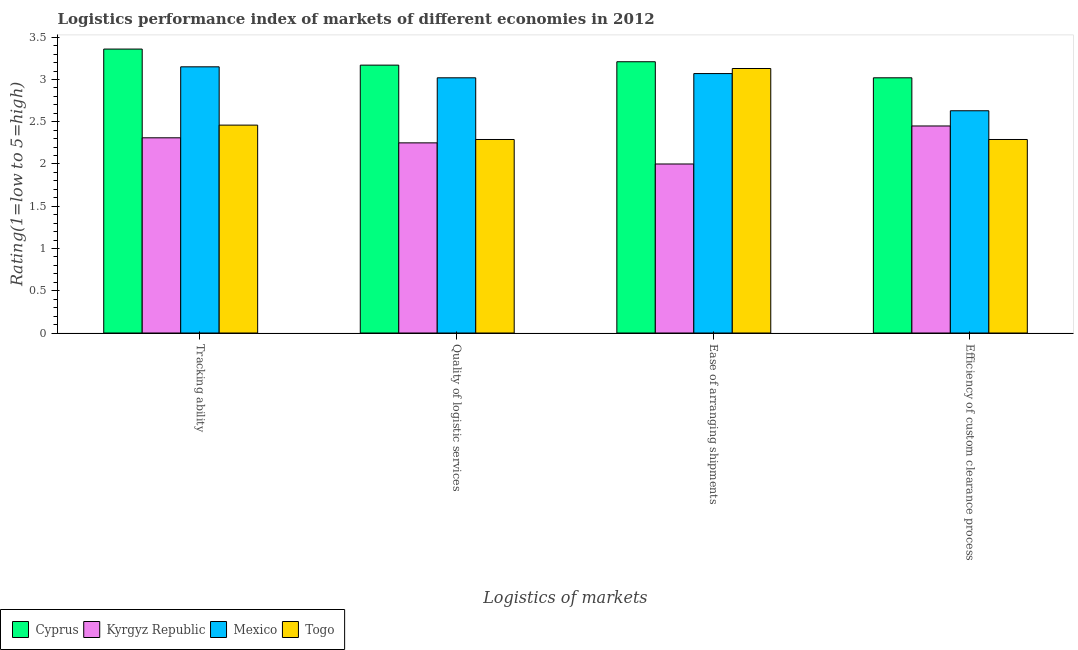How many different coloured bars are there?
Your response must be concise. 4. How many groups of bars are there?
Your answer should be compact. 4. How many bars are there on the 4th tick from the right?
Provide a short and direct response. 4. What is the label of the 1st group of bars from the left?
Make the answer very short. Tracking ability. Across all countries, what is the maximum lpi rating of efficiency of custom clearance process?
Make the answer very short. 3.02. Across all countries, what is the minimum lpi rating of quality of logistic services?
Your answer should be compact. 2.25. In which country was the lpi rating of efficiency of custom clearance process maximum?
Ensure brevity in your answer.  Cyprus. In which country was the lpi rating of quality of logistic services minimum?
Give a very brief answer. Kyrgyz Republic. What is the total lpi rating of ease of arranging shipments in the graph?
Offer a terse response. 11.41. What is the difference between the lpi rating of tracking ability in Kyrgyz Republic and that in Mexico?
Give a very brief answer. -0.84. What is the difference between the lpi rating of efficiency of custom clearance process in Mexico and the lpi rating of tracking ability in Cyprus?
Ensure brevity in your answer.  -0.73. What is the average lpi rating of ease of arranging shipments per country?
Provide a succinct answer. 2.85. What is the difference between the lpi rating of efficiency of custom clearance process and lpi rating of ease of arranging shipments in Cyprus?
Provide a short and direct response. -0.19. In how many countries, is the lpi rating of tracking ability greater than 2.8 ?
Your answer should be very brief. 2. What is the ratio of the lpi rating of ease of arranging shipments in Kyrgyz Republic to that in Cyprus?
Your answer should be compact. 0.62. Is the difference between the lpi rating of quality of logistic services in Kyrgyz Republic and Mexico greater than the difference between the lpi rating of efficiency of custom clearance process in Kyrgyz Republic and Mexico?
Your answer should be very brief. No. What is the difference between the highest and the second highest lpi rating of ease of arranging shipments?
Your answer should be very brief. 0.08. What is the difference between the highest and the lowest lpi rating of quality of logistic services?
Give a very brief answer. 0.92. In how many countries, is the lpi rating of ease of arranging shipments greater than the average lpi rating of ease of arranging shipments taken over all countries?
Provide a succinct answer. 3. What does the 2nd bar from the left in Ease of arranging shipments represents?
Keep it short and to the point. Kyrgyz Republic. What does the 1st bar from the right in Quality of logistic services represents?
Make the answer very short. Togo. Is it the case that in every country, the sum of the lpi rating of tracking ability and lpi rating of quality of logistic services is greater than the lpi rating of ease of arranging shipments?
Keep it short and to the point. Yes. How many bars are there?
Provide a short and direct response. 16. How many countries are there in the graph?
Provide a succinct answer. 4. What is the difference between two consecutive major ticks on the Y-axis?
Give a very brief answer. 0.5. Are the values on the major ticks of Y-axis written in scientific E-notation?
Give a very brief answer. No. Where does the legend appear in the graph?
Your answer should be very brief. Bottom left. How many legend labels are there?
Make the answer very short. 4. What is the title of the graph?
Provide a succinct answer. Logistics performance index of markets of different economies in 2012. What is the label or title of the X-axis?
Your answer should be very brief. Logistics of markets. What is the label or title of the Y-axis?
Offer a terse response. Rating(1=low to 5=high). What is the Rating(1=low to 5=high) of Cyprus in Tracking ability?
Make the answer very short. 3.36. What is the Rating(1=low to 5=high) in Kyrgyz Republic in Tracking ability?
Offer a terse response. 2.31. What is the Rating(1=low to 5=high) in Mexico in Tracking ability?
Ensure brevity in your answer.  3.15. What is the Rating(1=low to 5=high) of Togo in Tracking ability?
Keep it short and to the point. 2.46. What is the Rating(1=low to 5=high) in Cyprus in Quality of logistic services?
Provide a short and direct response. 3.17. What is the Rating(1=low to 5=high) in Kyrgyz Republic in Quality of logistic services?
Provide a short and direct response. 2.25. What is the Rating(1=low to 5=high) in Mexico in Quality of logistic services?
Provide a succinct answer. 3.02. What is the Rating(1=low to 5=high) in Togo in Quality of logistic services?
Your response must be concise. 2.29. What is the Rating(1=low to 5=high) of Cyprus in Ease of arranging shipments?
Ensure brevity in your answer.  3.21. What is the Rating(1=low to 5=high) in Mexico in Ease of arranging shipments?
Your response must be concise. 3.07. What is the Rating(1=low to 5=high) of Togo in Ease of arranging shipments?
Provide a succinct answer. 3.13. What is the Rating(1=low to 5=high) of Cyprus in Efficiency of custom clearance process?
Make the answer very short. 3.02. What is the Rating(1=low to 5=high) of Kyrgyz Republic in Efficiency of custom clearance process?
Offer a terse response. 2.45. What is the Rating(1=low to 5=high) in Mexico in Efficiency of custom clearance process?
Provide a succinct answer. 2.63. What is the Rating(1=low to 5=high) of Togo in Efficiency of custom clearance process?
Provide a short and direct response. 2.29. Across all Logistics of markets, what is the maximum Rating(1=low to 5=high) in Cyprus?
Your response must be concise. 3.36. Across all Logistics of markets, what is the maximum Rating(1=low to 5=high) in Kyrgyz Republic?
Your answer should be compact. 2.45. Across all Logistics of markets, what is the maximum Rating(1=low to 5=high) in Mexico?
Offer a very short reply. 3.15. Across all Logistics of markets, what is the maximum Rating(1=low to 5=high) in Togo?
Provide a succinct answer. 3.13. Across all Logistics of markets, what is the minimum Rating(1=low to 5=high) of Cyprus?
Offer a terse response. 3.02. Across all Logistics of markets, what is the minimum Rating(1=low to 5=high) of Mexico?
Your answer should be compact. 2.63. Across all Logistics of markets, what is the minimum Rating(1=low to 5=high) in Togo?
Make the answer very short. 2.29. What is the total Rating(1=low to 5=high) in Cyprus in the graph?
Your answer should be compact. 12.76. What is the total Rating(1=low to 5=high) of Kyrgyz Republic in the graph?
Your response must be concise. 9.01. What is the total Rating(1=low to 5=high) in Mexico in the graph?
Make the answer very short. 11.87. What is the total Rating(1=low to 5=high) in Togo in the graph?
Your answer should be compact. 10.17. What is the difference between the Rating(1=low to 5=high) of Cyprus in Tracking ability and that in Quality of logistic services?
Your response must be concise. 0.19. What is the difference between the Rating(1=low to 5=high) in Kyrgyz Republic in Tracking ability and that in Quality of logistic services?
Your answer should be compact. 0.06. What is the difference between the Rating(1=low to 5=high) in Mexico in Tracking ability and that in Quality of logistic services?
Ensure brevity in your answer.  0.13. What is the difference between the Rating(1=low to 5=high) of Togo in Tracking ability and that in Quality of logistic services?
Ensure brevity in your answer.  0.17. What is the difference between the Rating(1=low to 5=high) of Kyrgyz Republic in Tracking ability and that in Ease of arranging shipments?
Offer a very short reply. 0.31. What is the difference between the Rating(1=low to 5=high) in Togo in Tracking ability and that in Ease of arranging shipments?
Offer a very short reply. -0.67. What is the difference between the Rating(1=low to 5=high) in Cyprus in Tracking ability and that in Efficiency of custom clearance process?
Keep it short and to the point. 0.34. What is the difference between the Rating(1=low to 5=high) in Kyrgyz Republic in Tracking ability and that in Efficiency of custom clearance process?
Provide a short and direct response. -0.14. What is the difference between the Rating(1=low to 5=high) of Mexico in Tracking ability and that in Efficiency of custom clearance process?
Your answer should be very brief. 0.52. What is the difference between the Rating(1=low to 5=high) in Togo in Tracking ability and that in Efficiency of custom clearance process?
Your answer should be very brief. 0.17. What is the difference between the Rating(1=low to 5=high) of Cyprus in Quality of logistic services and that in Ease of arranging shipments?
Provide a succinct answer. -0.04. What is the difference between the Rating(1=low to 5=high) in Togo in Quality of logistic services and that in Ease of arranging shipments?
Give a very brief answer. -0.84. What is the difference between the Rating(1=low to 5=high) in Cyprus in Quality of logistic services and that in Efficiency of custom clearance process?
Provide a succinct answer. 0.15. What is the difference between the Rating(1=low to 5=high) in Mexico in Quality of logistic services and that in Efficiency of custom clearance process?
Offer a very short reply. 0.39. What is the difference between the Rating(1=low to 5=high) of Togo in Quality of logistic services and that in Efficiency of custom clearance process?
Your answer should be very brief. 0. What is the difference between the Rating(1=low to 5=high) of Cyprus in Ease of arranging shipments and that in Efficiency of custom clearance process?
Ensure brevity in your answer.  0.19. What is the difference between the Rating(1=low to 5=high) of Kyrgyz Republic in Ease of arranging shipments and that in Efficiency of custom clearance process?
Your answer should be compact. -0.45. What is the difference between the Rating(1=low to 5=high) of Mexico in Ease of arranging shipments and that in Efficiency of custom clearance process?
Make the answer very short. 0.44. What is the difference between the Rating(1=low to 5=high) of Togo in Ease of arranging shipments and that in Efficiency of custom clearance process?
Your answer should be compact. 0.84. What is the difference between the Rating(1=low to 5=high) in Cyprus in Tracking ability and the Rating(1=low to 5=high) in Kyrgyz Republic in Quality of logistic services?
Provide a short and direct response. 1.11. What is the difference between the Rating(1=low to 5=high) in Cyprus in Tracking ability and the Rating(1=low to 5=high) in Mexico in Quality of logistic services?
Your answer should be compact. 0.34. What is the difference between the Rating(1=low to 5=high) of Cyprus in Tracking ability and the Rating(1=low to 5=high) of Togo in Quality of logistic services?
Your response must be concise. 1.07. What is the difference between the Rating(1=low to 5=high) of Kyrgyz Republic in Tracking ability and the Rating(1=low to 5=high) of Mexico in Quality of logistic services?
Offer a very short reply. -0.71. What is the difference between the Rating(1=low to 5=high) of Kyrgyz Republic in Tracking ability and the Rating(1=low to 5=high) of Togo in Quality of logistic services?
Your response must be concise. 0.02. What is the difference between the Rating(1=low to 5=high) in Mexico in Tracking ability and the Rating(1=low to 5=high) in Togo in Quality of logistic services?
Provide a succinct answer. 0.86. What is the difference between the Rating(1=low to 5=high) of Cyprus in Tracking ability and the Rating(1=low to 5=high) of Kyrgyz Republic in Ease of arranging shipments?
Offer a terse response. 1.36. What is the difference between the Rating(1=low to 5=high) in Cyprus in Tracking ability and the Rating(1=low to 5=high) in Mexico in Ease of arranging shipments?
Your answer should be compact. 0.29. What is the difference between the Rating(1=low to 5=high) of Cyprus in Tracking ability and the Rating(1=low to 5=high) of Togo in Ease of arranging shipments?
Provide a succinct answer. 0.23. What is the difference between the Rating(1=low to 5=high) in Kyrgyz Republic in Tracking ability and the Rating(1=low to 5=high) in Mexico in Ease of arranging shipments?
Provide a short and direct response. -0.76. What is the difference between the Rating(1=low to 5=high) in Kyrgyz Republic in Tracking ability and the Rating(1=low to 5=high) in Togo in Ease of arranging shipments?
Provide a short and direct response. -0.82. What is the difference between the Rating(1=low to 5=high) in Mexico in Tracking ability and the Rating(1=low to 5=high) in Togo in Ease of arranging shipments?
Provide a succinct answer. 0.02. What is the difference between the Rating(1=low to 5=high) in Cyprus in Tracking ability and the Rating(1=low to 5=high) in Kyrgyz Republic in Efficiency of custom clearance process?
Offer a very short reply. 0.91. What is the difference between the Rating(1=low to 5=high) in Cyprus in Tracking ability and the Rating(1=low to 5=high) in Mexico in Efficiency of custom clearance process?
Give a very brief answer. 0.73. What is the difference between the Rating(1=low to 5=high) in Cyprus in Tracking ability and the Rating(1=low to 5=high) in Togo in Efficiency of custom clearance process?
Your response must be concise. 1.07. What is the difference between the Rating(1=low to 5=high) of Kyrgyz Republic in Tracking ability and the Rating(1=low to 5=high) of Mexico in Efficiency of custom clearance process?
Provide a short and direct response. -0.32. What is the difference between the Rating(1=low to 5=high) in Kyrgyz Republic in Tracking ability and the Rating(1=low to 5=high) in Togo in Efficiency of custom clearance process?
Keep it short and to the point. 0.02. What is the difference between the Rating(1=low to 5=high) in Mexico in Tracking ability and the Rating(1=low to 5=high) in Togo in Efficiency of custom clearance process?
Make the answer very short. 0.86. What is the difference between the Rating(1=low to 5=high) of Cyprus in Quality of logistic services and the Rating(1=low to 5=high) of Kyrgyz Republic in Ease of arranging shipments?
Keep it short and to the point. 1.17. What is the difference between the Rating(1=low to 5=high) in Cyprus in Quality of logistic services and the Rating(1=low to 5=high) in Togo in Ease of arranging shipments?
Offer a terse response. 0.04. What is the difference between the Rating(1=low to 5=high) in Kyrgyz Republic in Quality of logistic services and the Rating(1=low to 5=high) in Mexico in Ease of arranging shipments?
Ensure brevity in your answer.  -0.82. What is the difference between the Rating(1=low to 5=high) in Kyrgyz Republic in Quality of logistic services and the Rating(1=low to 5=high) in Togo in Ease of arranging shipments?
Provide a succinct answer. -0.88. What is the difference between the Rating(1=low to 5=high) in Mexico in Quality of logistic services and the Rating(1=low to 5=high) in Togo in Ease of arranging shipments?
Your response must be concise. -0.11. What is the difference between the Rating(1=low to 5=high) of Cyprus in Quality of logistic services and the Rating(1=low to 5=high) of Kyrgyz Republic in Efficiency of custom clearance process?
Provide a short and direct response. 0.72. What is the difference between the Rating(1=low to 5=high) in Cyprus in Quality of logistic services and the Rating(1=low to 5=high) in Mexico in Efficiency of custom clearance process?
Your answer should be very brief. 0.54. What is the difference between the Rating(1=low to 5=high) in Cyprus in Quality of logistic services and the Rating(1=low to 5=high) in Togo in Efficiency of custom clearance process?
Provide a short and direct response. 0.88. What is the difference between the Rating(1=low to 5=high) of Kyrgyz Republic in Quality of logistic services and the Rating(1=low to 5=high) of Mexico in Efficiency of custom clearance process?
Your answer should be compact. -0.38. What is the difference between the Rating(1=low to 5=high) in Kyrgyz Republic in Quality of logistic services and the Rating(1=low to 5=high) in Togo in Efficiency of custom clearance process?
Provide a succinct answer. -0.04. What is the difference between the Rating(1=low to 5=high) of Mexico in Quality of logistic services and the Rating(1=low to 5=high) of Togo in Efficiency of custom clearance process?
Ensure brevity in your answer.  0.73. What is the difference between the Rating(1=low to 5=high) in Cyprus in Ease of arranging shipments and the Rating(1=low to 5=high) in Kyrgyz Republic in Efficiency of custom clearance process?
Ensure brevity in your answer.  0.76. What is the difference between the Rating(1=low to 5=high) in Cyprus in Ease of arranging shipments and the Rating(1=low to 5=high) in Mexico in Efficiency of custom clearance process?
Make the answer very short. 0.58. What is the difference between the Rating(1=low to 5=high) of Kyrgyz Republic in Ease of arranging shipments and the Rating(1=low to 5=high) of Mexico in Efficiency of custom clearance process?
Keep it short and to the point. -0.63. What is the difference between the Rating(1=low to 5=high) in Kyrgyz Republic in Ease of arranging shipments and the Rating(1=low to 5=high) in Togo in Efficiency of custom clearance process?
Keep it short and to the point. -0.29. What is the difference between the Rating(1=low to 5=high) in Mexico in Ease of arranging shipments and the Rating(1=low to 5=high) in Togo in Efficiency of custom clearance process?
Keep it short and to the point. 0.78. What is the average Rating(1=low to 5=high) of Cyprus per Logistics of markets?
Provide a succinct answer. 3.19. What is the average Rating(1=low to 5=high) in Kyrgyz Republic per Logistics of markets?
Make the answer very short. 2.25. What is the average Rating(1=low to 5=high) in Mexico per Logistics of markets?
Offer a very short reply. 2.97. What is the average Rating(1=low to 5=high) in Togo per Logistics of markets?
Make the answer very short. 2.54. What is the difference between the Rating(1=low to 5=high) of Cyprus and Rating(1=low to 5=high) of Mexico in Tracking ability?
Your answer should be very brief. 0.21. What is the difference between the Rating(1=low to 5=high) of Kyrgyz Republic and Rating(1=low to 5=high) of Mexico in Tracking ability?
Your response must be concise. -0.84. What is the difference between the Rating(1=low to 5=high) in Kyrgyz Republic and Rating(1=low to 5=high) in Togo in Tracking ability?
Offer a very short reply. -0.15. What is the difference between the Rating(1=low to 5=high) of Mexico and Rating(1=low to 5=high) of Togo in Tracking ability?
Provide a short and direct response. 0.69. What is the difference between the Rating(1=low to 5=high) of Cyprus and Rating(1=low to 5=high) of Kyrgyz Republic in Quality of logistic services?
Your answer should be very brief. 0.92. What is the difference between the Rating(1=low to 5=high) in Cyprus and Rating(1=low to 5=high) in Togo in Quality of logistic services?
Ensure brevity in your answer.  0.88. What is the difference between the Rating(1=low to 5=high) in Kyrgyz Republic and Rating(1=low to 5=high) in Mexico in Quality of logistic services?
Give a very brief answer. -0.77. What is the difference between the Rating(1=low to 5=high) in Kyrgyz Republic and Rating(1=low to 5=high) in Togo in Quality of logistic services?
Provide a short and direct response. -0.04. What is the difference between the Rating(1=low to 5=high) of Mexico and Rating(1=low to 5=high) of Togo in Quality of logistic services?
Provide a short and direct response. 0.73. What is the difference between the Rating(1=low to 5=high) of Cyprus and Rating(1=low to 5=high) of Kyrgyz Republic in Ease of arranging shipments?
Your answer should be very brief. 1.21. What is the difference between the Rating(1=low to 5=high) of Cyprus and Rating(1=low to 5=high) of Mexico in Ease of arranging shipments?
Make the answer very short. 0.14. What is the difference between the Rating(1=low to 5=high) in Cyprus and Rating(1=low to 5=high) in Togo in Ease of arranging shipments?
Provide a short and direct response. 0.08. What is the difference between the Rating(1=low to 5=high) in Kyrgyz Republic and Rating(1=low to 5=high) in Mexico in Ease of arranging shipments?
Your answer should be compact. -1.07. What is the difference between the Rating(1=low to 5=high) in Kyrgyz Republic and Rating(1=low to 5=high) in Togo in Ease of arranging shipments?
Offer a terse response. -1.13. What is the difference between the Rating(1=low to 5=high) in Mexico and Rating(1=low to 5=high) in Togo in Ease of arranging shipments?
Your answer should be compact. -0.06. What is the difference between the Rating(1=low to 5=high) in Cyprus and Rating(1=low to 5=high) in Kyrgyz Republic in Efficiency of custom clearance process?
Your response must be concise. 0.57. What is the difference between the Rating(1=low to 5=high) in Cyprus and Rating(1=low to 5=high) in Mexico in Efficiency of custom clearance process?
Provide a short and direct response. 0.39. What is the difference between the Rating(1=low to 5=high) in Cyprus and Rating(1=low to 5=high) in Togo in Efficiency of custom clearance process?
Ensure brevity in your answer.  0.73. What is the difference between the Rating(1=low to 5=high) in Kyrgyz Republic and Rating(1=low to 5=high) in Mexico in Efficiency of custom clearance process?
Your answer should be very brief. -0.18. What is the difference between the Rating(1=low to 5=high) in Kyrgyz Republic and Rating(1=low to 5=high) in Togo in Efficiency of custom clearance process?
Offer a terse response. 0.16. What is the difference between the Rating(1=low to 5=high) in Mexico and Rating(1=low to 5=high) in Togo in Efficiency of custom clearance process?
Offer a terse response. 0.34. What is the ratio of the Rating(1=low to 5=high) of Cyprus in Tracking ability to that in Quality of logistic services?
Keep it short and to the point. 1.06. What is the ratio of the Rating(1=low to 5=high) in Kyrgyz Republic in Tracking ability to that in Quality of logistic services?
Give a very brief answer. 1.03. What is the ratio of the Rating(1=low to 5=high) in Mexico in Tracking ability to that in Quality of logistic services?
Keep it short and to the point. 1.04. What is the ratio of the Rating(1=low to 5=high) of Togo in Tracking ability to that in Quality of logistic services?
Keep it short and to the point. 1.07. What is the ratio of the Rating(1=low to 5=high) in Cyprus in Tracking ability to that in Ease of arranging shipments?
Provide a succinct answer. 1.05. What is the ratio of the Rating(1=low to 5=high) in Kyrgyz Republic in Tracking ability to that in Ease of arranging shipments?
Provide a succinct answer. 1.16. What is the ratio of the Rating(1=low to 5=high) in Mexico in Tracking ability to that in Ease of arranging shipments?
Make the answer very short. 1.03. What is the ratio of the Rating(1=low to 5=high) of Togo in Tracking ability to that in Ease of arranging shipments?
Provide a short and direct response. 0.79. What is the ratio of the Rating(1=low to 5=high) of Cyprus in Tracking ability to that in Efficiency of custom clearance process?
Provide a short and direct response. 1.11. What is the ratio of the Rating(1=low to 5=high) in Kyrgyz Republic in Tracking ability to that in Efficiency of custom clearance process?
Your response must be concise. 0.94. What is the ratio of the Rating(1=low to 5=high) in Mexico in Tracking ability to that in Efficiency of custom clearance process?
Offer a very short reply. 1.2. What is the ratio of the Rating(1=low to 5=high) of Togo in Tracking ability to that in Efficiency of custom clearance process?
Your answer should be very brief. 1.07. What is the ratio of the Rating(1=low to 5=high) of Cyprus in Quality of logistic services to that in Ease of arranging shipments?
Your answer should be compact. 0.99. What is the ratio of the Rating(1=low to 5=high) in Mexico in Quality of logistic services to that in Ease of arranging shipments?
Your answer should be compact. 0.98. What is the ratio of the Rating(1=low to 5=high) in Togo in Quality of logistic services to that in Ease of arranging shipments?
Give a very brief answer. 0.73. What is the ratio of the Rating(1=low to 5=high) of Cyprus in Quality of logistic services to that in Efficiency of custom clearance process?
Ensure brevity in your answer.  1.05. What is the ratio of the Rating(1=low to 5=high) of Kyrgyz Republic in Quality of logistic services to that in Efficiency of custom clearance process?
Provide a short and direct response. 0.92. What is the ratio of the Rating(1=low to 5=high) in Mexico in Quality of logistic services to that in Efficiency of custom clearance process?
Make the answer very short. 1.15. What is the ratio of the Rating(1=low to 5=high) in Togo in Quality of logistic services to that in Efficiency of custom clearance process?
Provide a short and direct response. 1. What is the ratio of the Rating(1=low to 5=high) in Cyprus in Ease of arranging shipments to that in Efficiency of custom clearance process?
Your response must be concise. 1.06. What is the ratio of the Rating(1=low to 5=high) of Kyrgyz Republic in Ease of arranging shipments to that in Efficiency of custom clearance process?
Offer a terse response. 0.82. What is the ratio of the Rating(1=low to 5=high) in Mexico in Ease of arranging shipments to that in Efficiency of custom clearance process?
Offer a very short reply. 1.17. What is the ratio of the Rating(1=low to 5=high) in Togo in Ease of arranging shipments to that in Efficiency of custom clearance process?
Offer a very short reply. 1.37. What is the difference between the highest and the second highest Rating(1=low to 5=high) of Kyrgyz Republic?
Your response must be concise. 0.14. What is the difference between the highest and the second highest Rating(1=low to 5=high) in Mexico?
Your answer should be compact. 0.08. What is the difference between the highest and the second highest Rating(1=low to 5=high) of Togo?
Provide a short and direct response. 0.67. What is the difference between the highest and the lowest Rating(1=low to 5=high) in Cyprus?
Ensure brevity in your answer.  0.34. What is the difference between the highest and the lowest Rating(1=low to 5=high) of Kyrgyz Republic?
Your answer should be compact. 0.45. What is the difference between the highest and the lowest Rating(1=low to 5=high) of Mexico?
Keep it short and to the point. 0.52. What is the difference between the highest and the lowest Rating(1=low to 5=high) in Togo?
Your answer should be very brief. 0.84. 